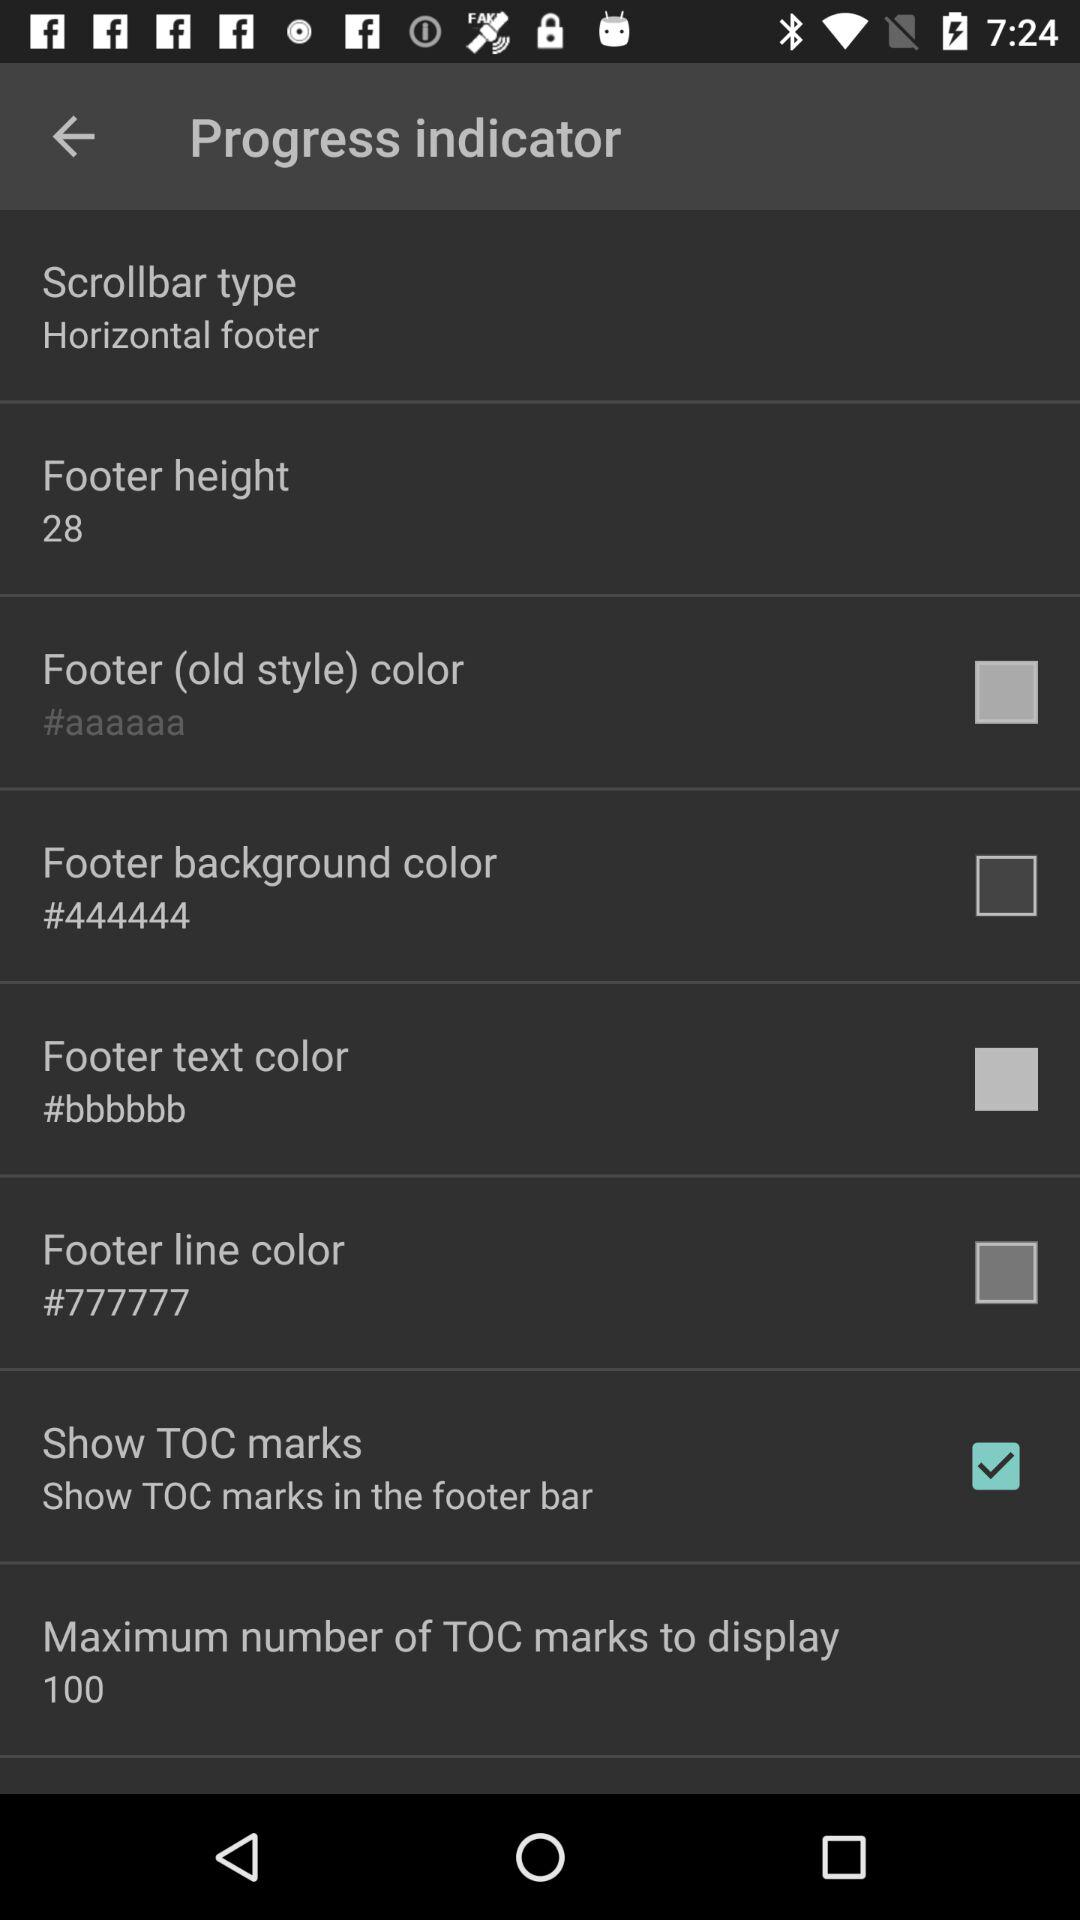What is the maximum number of TOC marks to display? The maximum number of TOC marks to display is 100. 